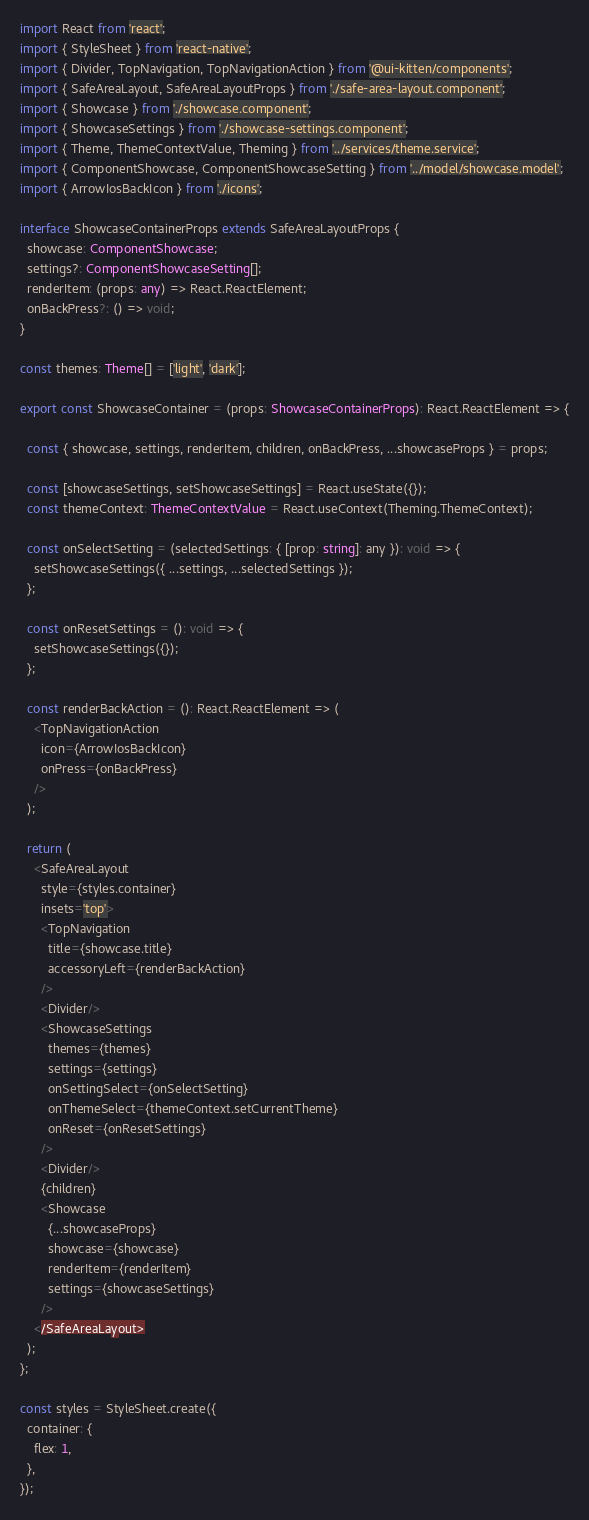<code> <loc_0><loc_0><loc_500><loc_500><_TypeScript_>import React from 'react';
import { StyleSheet } from 'react-native';
import { Divider, TopNavigation, TopNavigationAction } from '@ui-kitten/components';
import { SafeAreaLayout, SafeAreaLayoutProps } from './safe-area-layout.component';
import { Showcase } from './showcase.component';
import { ShowcaseSettings } from './showcase-settings.component';
import { Theme, ThemeContextValue, Theming } from '../services/theme.service';
import { ComponentShowcase, ComponentShowcaseSetting } from '../model/showcase.model';
import { ArrowIosBackIcon } from './icons';

interface ShowcaseContainerProps extends SafeAreaLayoutProps {
  showcase: ComponentShowcase;
  settings?: ComponentShowcaseSetting[];
  renderItem: (props: any) => React.ReactElement;
  onBackPress?: () => void;
}

const themes: Theme[] = ['light', 'dark'];

export const ShowcaseContainer = (props: ShowcaseContainerProps): React.ReactElement => {

  const { showcase, settings, renderItem, children, onBackPress, ...showcaseProps } = props;

  const [showcaseSettings, setShowcaseSettings] = React.useState({});
  const themeContext: ThemeContextValue = React.useContext(Theming.ThemeContext);

  const onSelectSetting = (selectedSettings: { [prop: string]: any }): void => {
    setShowcaseSettings({ ...settings, ...selectedSettings });
  };

  const onResetSettings = (): void => {
    setShowcaseSettings({});
  };

  const renderBackAction = (): React.ReactElement => (
    <TopNavigationAction
      icon={ArrowIosBackIcon}
      onPress={onBackPress}
    />
  );

  return (
    <SafeAreaLayout
      style={styles.container}
      insets='top'>
      <TopNavigation
        title={showcase.title}
        accessoryLeft={renderBackAction}
      />
      <Divider/>
      <ShowcaseSettings
        themes={themes}
        settings={settings}
        onSettingSelect={onSelectSetting}
        onThemeSelect={themeContext.setCurrentTheme}
        onReset={onResetSettings}
      />
      <Divider/>
      {children}
      <Showcase
        {...showcaseProps}
        showcase={showcase}
        renderItem={renderItem}
        settings={showcaseSettings}
      />
    </SafeAreaLayout>
  );
};

const styles = StyleSheet.create({
  container: {
    flex: 1,
  },
});
</code> 